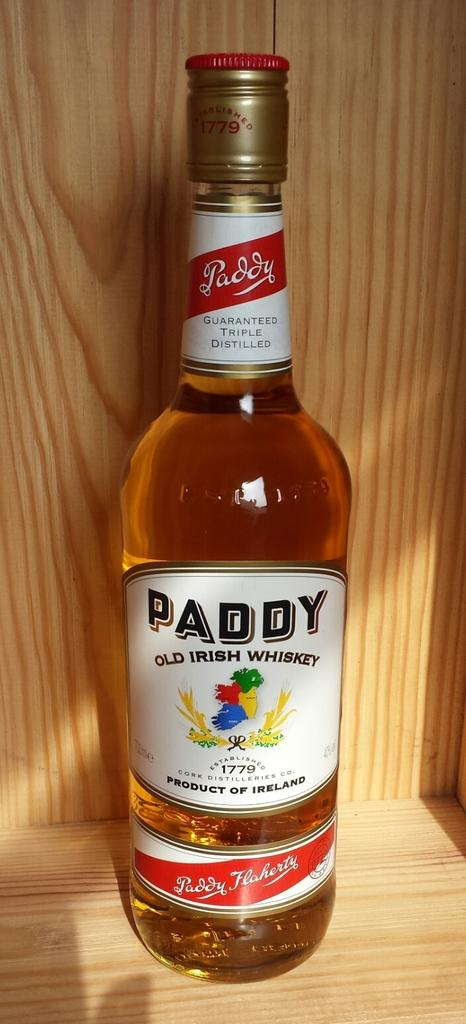<image>
Write a terse but informative summary of the picture. A full bottle of Paddy whiskey still has the gold seal intact. 